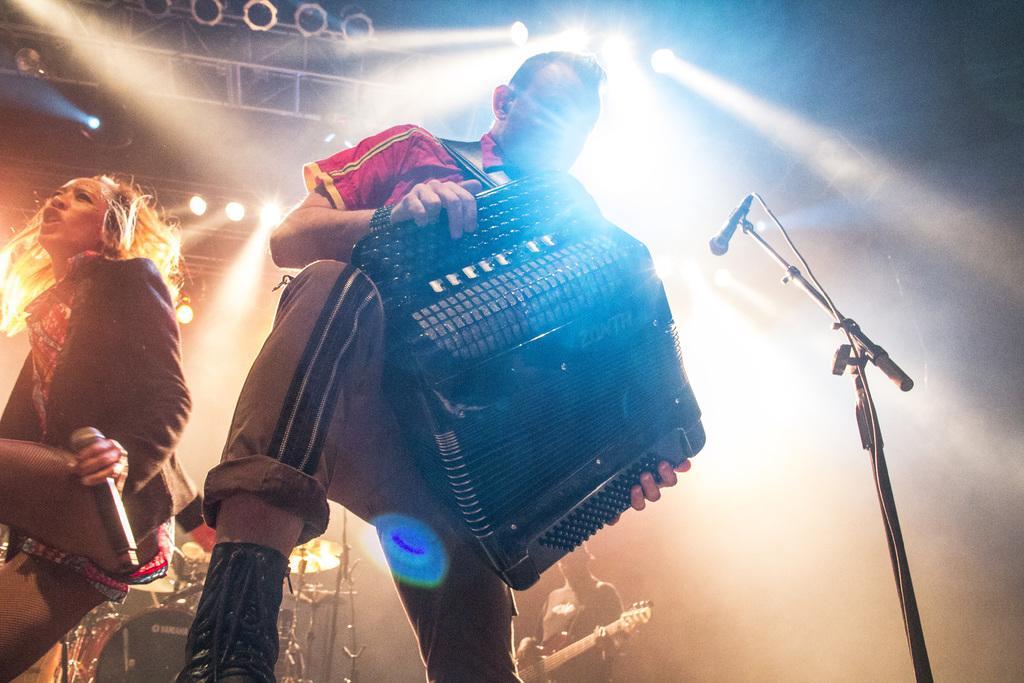How would you summarize this image in a sentence or two? In this image I can see a man and a woman where he is holding a musical instrument and she is holding a mic. Here I can see one more mic. In the background I can see or more person holding a guitar. 